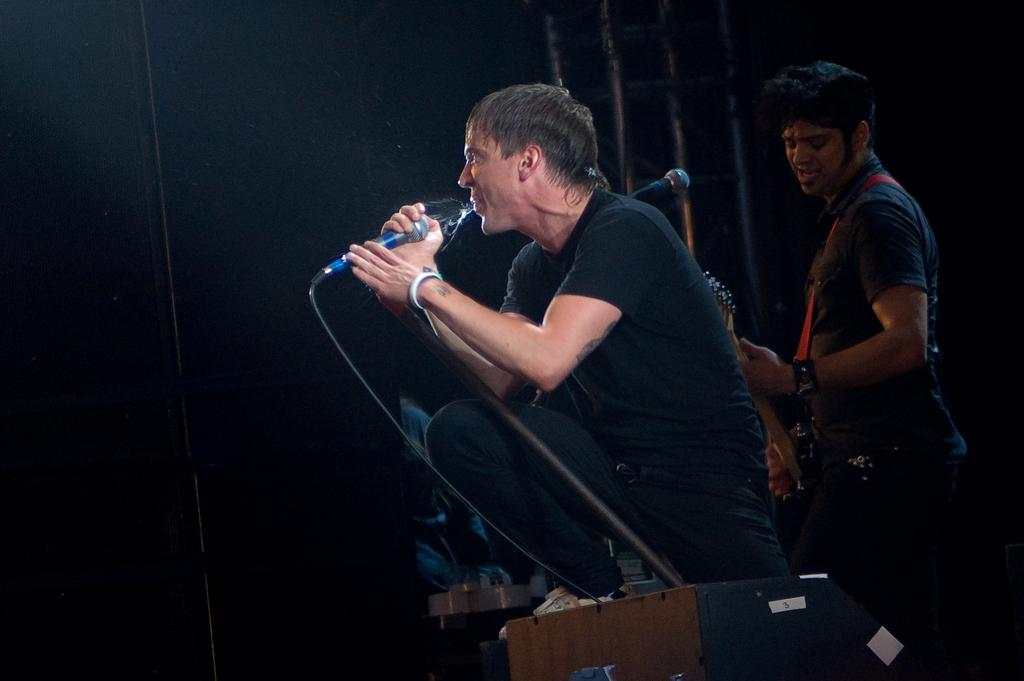How many people are in the image? There are two people in the image. What are the two people doing in the image? One person is holding a microphone and singing, while the other person is holding a guitar and playing it. What type of needle is being used to play the guitar in the image? There is no needle present in the image; the person is playing the guitar with their hands. 